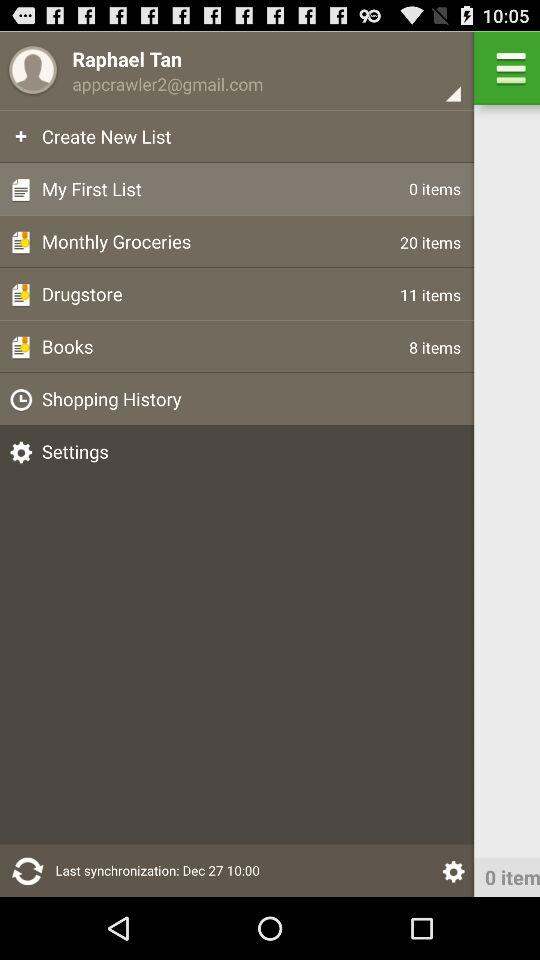What is the last synchronization time? The time is 10:00. 